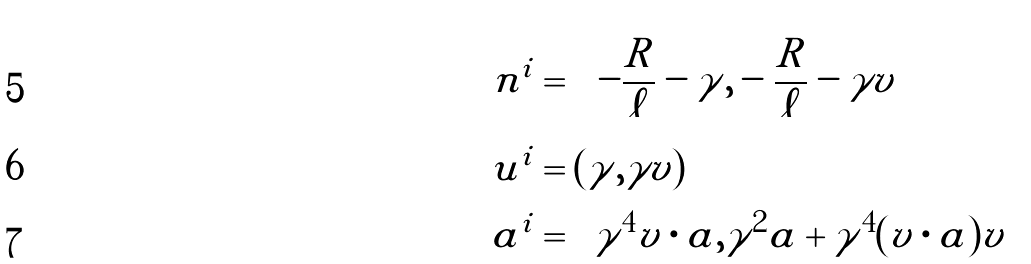<formula> <loc_0><loc_0><loc_500><loc_500>n ^ { i } & = \left ( - \frac { R } { \ell } - \gamma , - \frac { R } { \ell } - \gamma v \right ) \\ u ^ { i } & = ( \gamma , \gamma v ) \\ a ^ { i } & = \left ( \gamma ^ { 4 } v \cdot a , \gamma ^ { 2 } a + \gamma ^ { 4 } ( v \cdot a ) v \right )</formula> 